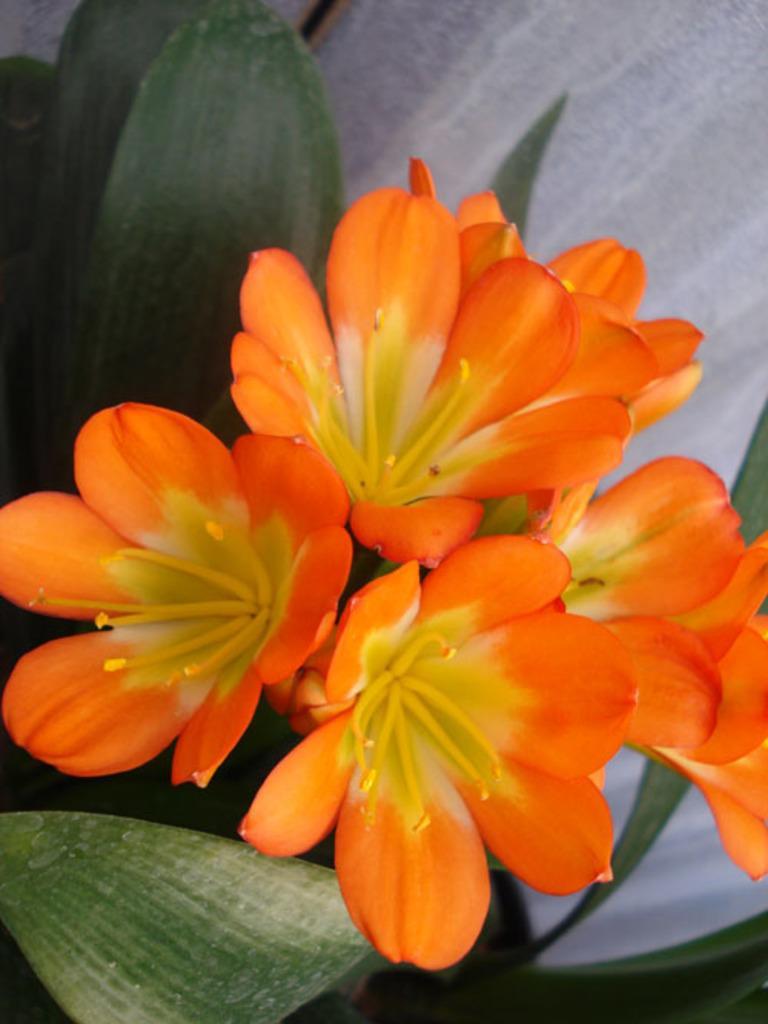Please provide a concise description of this image. In this picture I can see a plant with orange flowers, this is looking like a wall. 